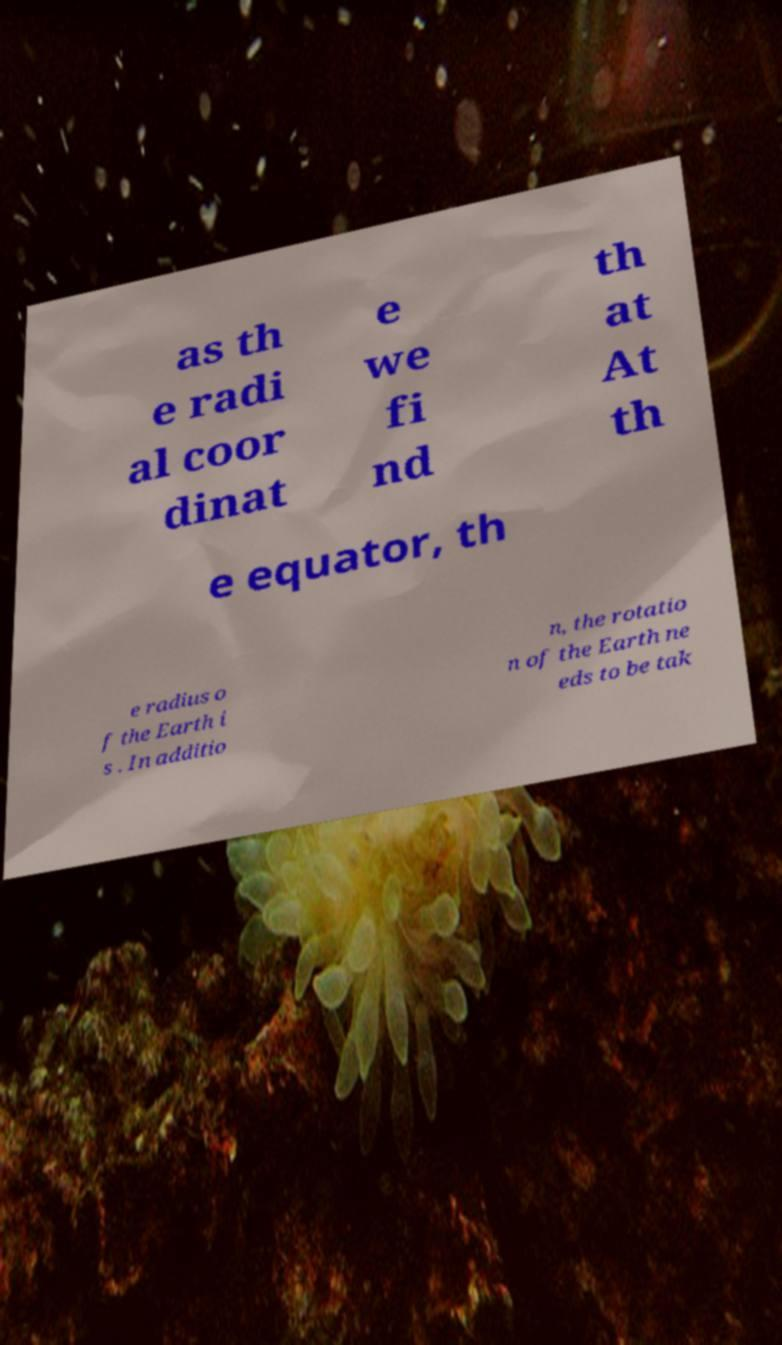For documentation purposes, I need the text within this image transcribed. Could you provide that? as th e radi al coor dinat e we fi nd th at At th e equator, th e radius o f the Earth i s . In additio n, the rotatio n of the Earth ne eds to be tak 